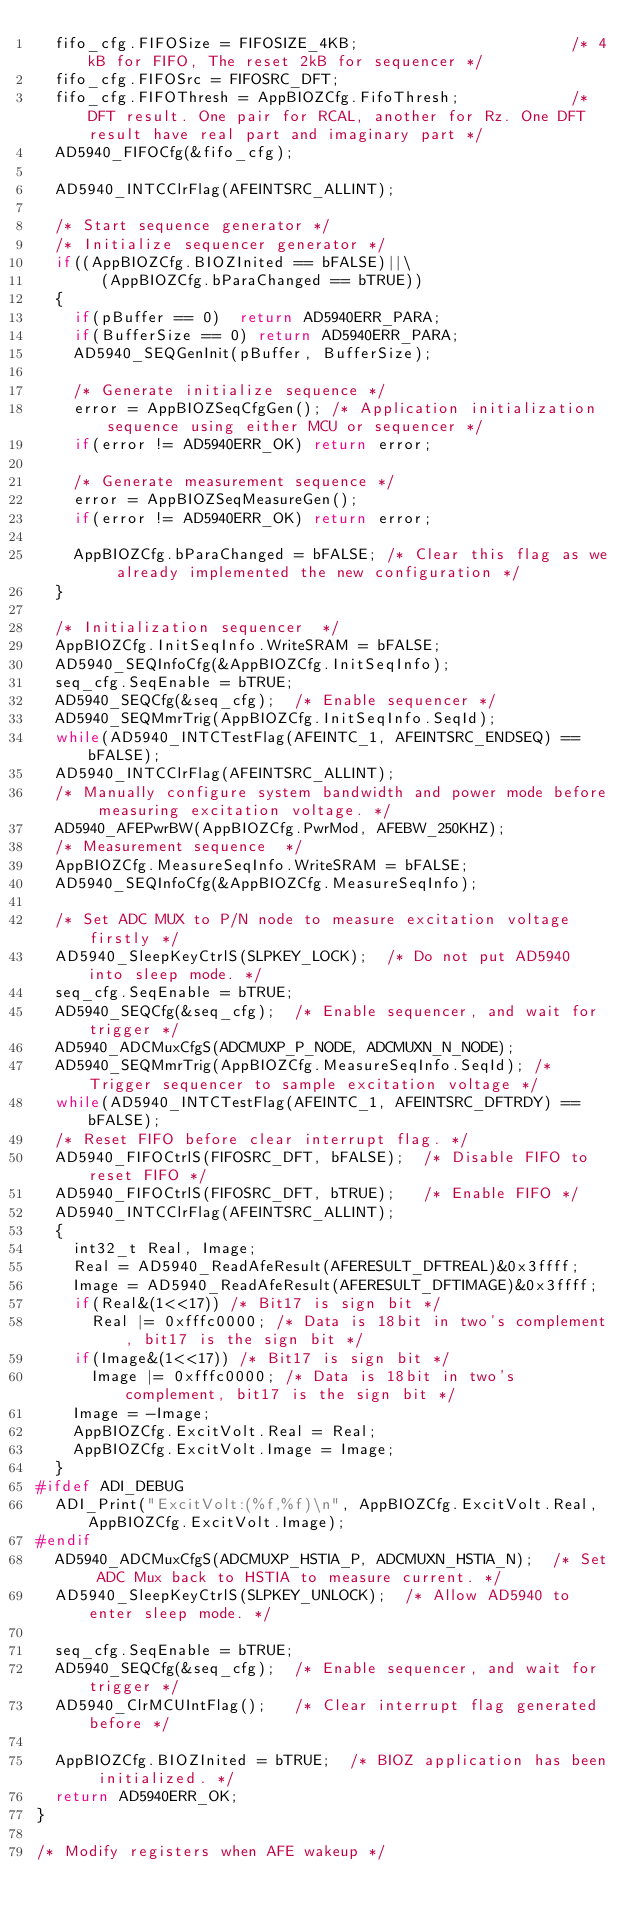Convert code to text. <code><loc_0><loc_0><loc_500><loc_500><_C_>  fifo_cfg.FIFOSize = FIFOSIZE_4KB;                       /* 4kB for FIFO, The reset 2kB for sequencer */
  fifo_cfg.FIFOSrc = FIFOSRC_DFT;
  fifo_cfg.FIFOThresh = AppBIOZCfg.FifoThresh;            /* DFT result. One pair for RCAL, another for Rz. One DFT result have real part and imaginary part */
  AD5940_FIFOCfg(&fifo_cfg);

  AD5940_INTCClrFlag(AFEINTSRC_ALLINT);
  
  /* Start sequence generator */
  /* Initialize sequencer generator */
  if((AppBIOZCfg.BIOZInited == bFALSE)||\
       (AppBIOZCfg.bParaChanged == bTRUE))
  {
    if(pBuffer == 0)  return AD5940ERR_PARA;
    if(BufferSize == 0) return AD5940ERR_PARA;   
    AD5940_SEQGenInit(pBuffer, BufferSize);

    /* Generate initialize sequence */
    error = AppBIOZSeqCfgGen(); /* Application initialization sequence using either MCU or sequencer */
    if(error != AD5940ERR_OK) return error;

    /* Generate measurement sequence */
    error = AppBIOZSeqMeasureGen();
    if(error != AD5940ERR_OK) return error;

    AppBIOZCfg.bParaChanged = bFALSE; /* Clear this flag as we already implemented the new configuration */
  }

  /* Initialization sequencer  */
  AppBIOZCfg.InitSeqInfo.WriteSRAM = bFALSE;
  AD5940_SEQInfoCfg(&AppBIOZCfg.InitSeqInfo);
  seq_cfg.SeqEnable = bTRUE;
  AD5940_SEQCfg(&seq_cfg);  /* Enable sequencer */
  AD5940_SEQMmrTrig(AppBIOZCfg.InitSeqInfo.SeqId);
  while(AD5940_INTCTestFlag(AFEINTC_1, AFEINTSRC_ENDSEQ) == bFALSE);
  AD5940_INTCClrFlag(AFEINTSRC_ALLINT);
	/* Manually configure system bandwidth and power mode before measuring excitation voltage. */
  AD5940_AFEPwrBW(AppBIOZCfg.PwrMod, AFEBW_250KHZ);
  /* Measurement sequence  */
  AppBIOZCfg.MeasureSeqInfo.WriteSRAM = bFALSE;
  AD5940_SEQInfoCfg(&AppBIOZCfg.MeasureSeqInfo);
  
  /* Set ADC MUX to P/N node to measure excitation voltage firstly */
	AD5940_SleepKeyCtrlS(SLPKEY_LOCK);	/* Do not put AD5940 into sleep mode. */
  seq_cfg.SeqEnable = bTRUE;
  AD5940_SEQCfg(&seq_cfg);  /* Enable sequencer, and wait for trigger */
  AD5940_ADCMuxCfgS(ADCMUXP_P_NODE, ADCMUXN_N_NODE);
  AD5940_SEQMmrTrig(AppBIOZCfg.MeasureSeqInfo.SeqId); /* Trigger sequencer to sample excitation voltage */
  while(AD5940_INTCTestFlag(AFEINTC_1, AFEINTSRC_DFTRDY) == bFALSE);
	/* Reset FIFO before clear interrupt flag. */
  AD5940_FIFOCtrlS(FIFOSRC_DFT, bFALSE);  /* Disable FIFO to reset FIFO */
  AD5940_FIFOCtrlS(FIFOSRC_DFT, bTRUE);   /* Enable FIFO */
  AD5940_INTCClrFlag(AFEINTSRC_ALLINT);
  {
    int32_t Real, Image;
    Real = AD5940_ReadAfeResult(AFERESULT_DFTREAL)&0x3ffff;
    Image = AD5940_ReadAfeResult(AFERESULT_DFTIMAGE)&0x3ffff;
    if(Real&(1<<17)) /* Bit17 is sign bit */
      Real |= 0xfffc0000; /* Data is 18bit in two's complement, bit17 is the sign bit */
    if(Image&(1<<17)) /* Bit17 is sign bit */
      Image |= 0xfffc0000; /* Data is 18bit in two's complement, bit17 is the sign bit */
    Image = -Image;
    AppBIOZCfg.ExcitVolt.Real = Real;
    AppBIOZCfg.ExcitVolt.Image = Image;
  }
#ifdef ADI_DEBUG
  ADI_Print("ExcitVolt:(%f,%f)\n", AppBIOZCfg.ExcitVolt.Real, AppBIOZCfg.ExcitVolt.Image);
#endif
  AD5940_ADCMuxCfgS(ADCMUXP_HSTIA_P, ADCMUXN_HSTIA_N);	/* Set ADC Mux back to HSTIA to measure current. */
	AD5940_SleepKeyCtrlS(SLPKEY_UNLOCK);	/* Allow AD5940 to enter sleep mode. */

  seq_cfg.SeqEnable = bTRUE;
  AD5940_SEQCfg(&seq_cfg);  /* Enable sequencer, and wait for trigger */
  AD5940_ClrMCUIntFlag();   /* Clear interrupt flag generated before */

  AppBIOZCfg.BIOZInited = bTRUE;  /* BIOZ application has been initialized. */
  return AD5940ERR_OK;
}

/* Modify registers when AFE wakeup */</code> 